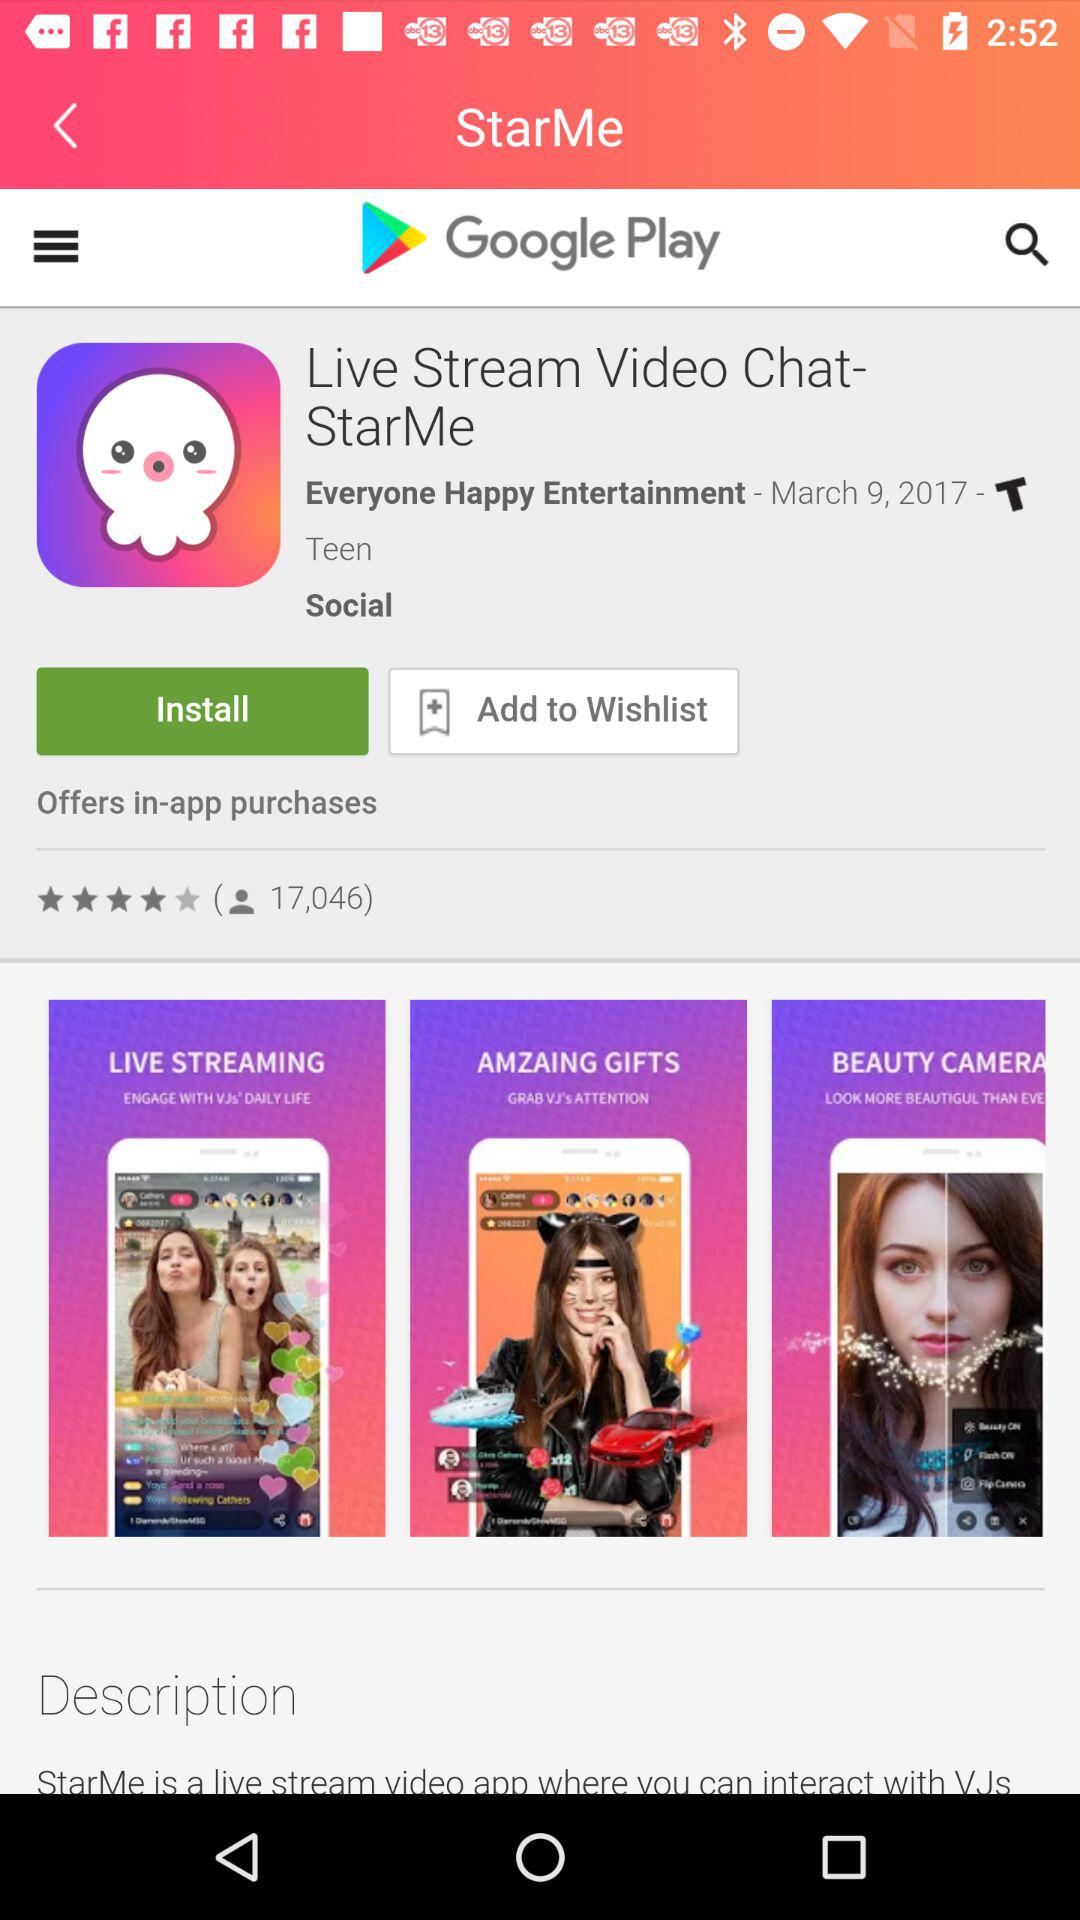"Live Stream Video Chat-StarMe" is updated on what date? The date is March 9, 2017. 